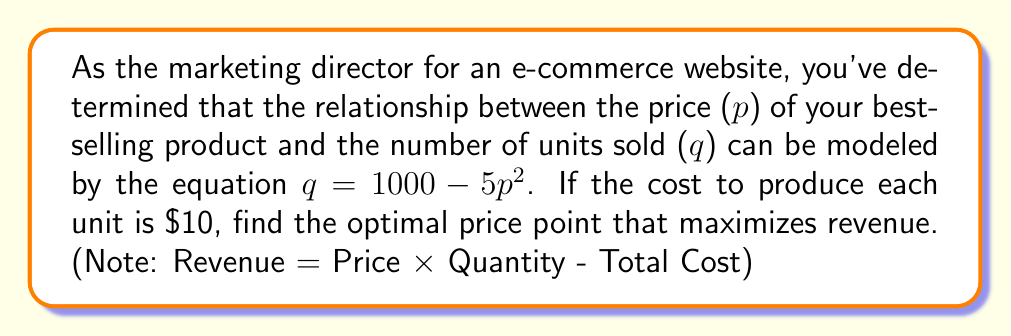Give your solution to this math problem. 1) First, let's express revenue (R) in terms of price (p):
   $R = p \times q - 10q$
   $R = p(1000 - 5p^2) - 10(1000 - 5p^2)$
   $R = 1000p - 5p^3 - 10000 + 50p^2$
   $R = -5p^3 + 50p^2 + 1000p - 10000$

2) To find the maximum revenue, we need to find where the derivative of R with respect to p equals zero:
   $\frac{dR}{dp} = -15p^2 + 100p + 1000$

3) Set this equal to zero and solve:
   $-15p^2 + 100p + 1000 = 0$
   $-3p^2 + 20p + 200 = 0$

4) This is a quadratic equation. We can solve it using the quadratic formula:
   $p = \frac{-b \pm \sqrt{b^2 - 4ac}}{2a}$
   Where $a = -3$, $b = 20$, and $c = 200$

5) Plugging in these values:
   $p = \frac{-20 \pm \sqrt{400 - 4(-3)(200)}}{2(-3)}$
   $p = \frac{-20 \pm \sqrt{2800}}{-6}$
   $p = \frac{-20 \pm 52.92}{-6}$

6) This gives us two solutions:
   $p_1 = \frac{-20 + 52.92}{-6} \approx 5.49$
   $p_2 = \frac{-20 - 52.92}{-6} \approx 12.15$

7) The second derivative of R is $-30p + 100$. At $p = 12.15$, this is negative, indicating a maximum.

Therefore, the optimal price point that maximizes revenue is approximately $12.15.
Answer: $12.15 